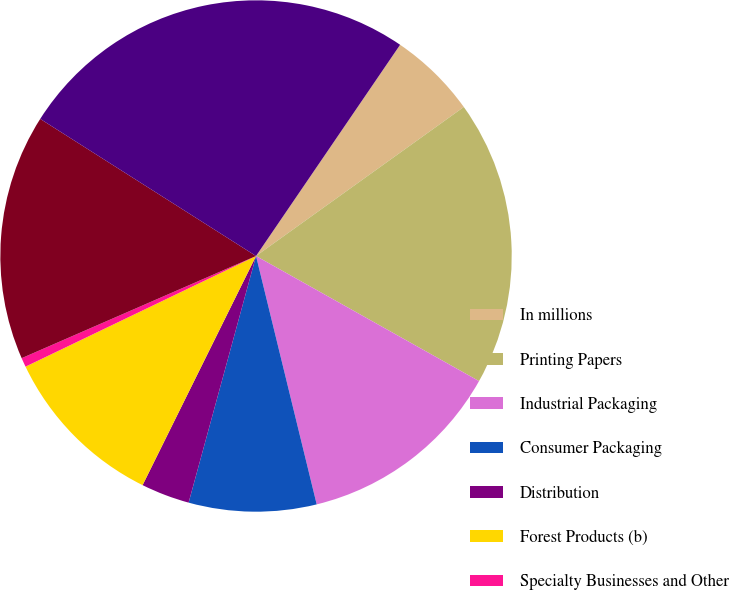Convert chart. <chart><loc_0><loc_0><loc_500><loc_500><pie_chart><fcel>In millions<fcel>Printing Papers<fcel>Industrial Packaging<fcel>Consumer Packaging<fcel>Distribution<fcel>Forest Products (b)<fcel>Specialty Businesses and Other<fcel>Corporate and other (c)<fcel>Assets<nl><fcel>5.57%<fcel>18.04%<fcel>13.05%<fcel>8.06%<fcel>3.07%<fcel>10.56%<fcel>0.58%<fcel>15.55%<fcel>25.52%<nl></chart> 